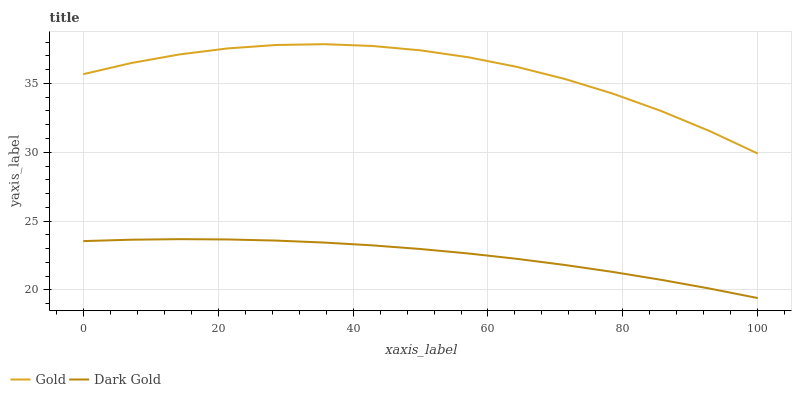Does Dark Gold have the minimum area under the curve?
Answer yes or no. Yes. Does Gold have the maximum area under the curve?
Answer yes or no. Yes. Does Dark Gold have the maximum area under the curve?
Answer yes or no. No. Is Dark Gold the smoothest?
Answer yes or no. Yes. Is Gold the roughest?
Answer yes or no. Yes. Is Dark Gold the roughest?
Answer yes or no. No. Does Dark Gold have the lowest value?
Answer yes or no. Yes. Does Gold have the highest value?
Answer yes or no. Yes. Does Dark Gold have the highest value?
Answer yes or no. No. Is Dark Gold less than Gold?
Answer yes or no. Yes. Is Gold greater than Dark Gold?
Answer yes or no. Yes. Does Dark Gold intersect Gold?
Answer yes or no. No. 